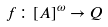<formula> <loc_0><loc_0><loc_500><loc_500>f \colon [ A ] ^ { \omega } \rightarrow Q</formula> 